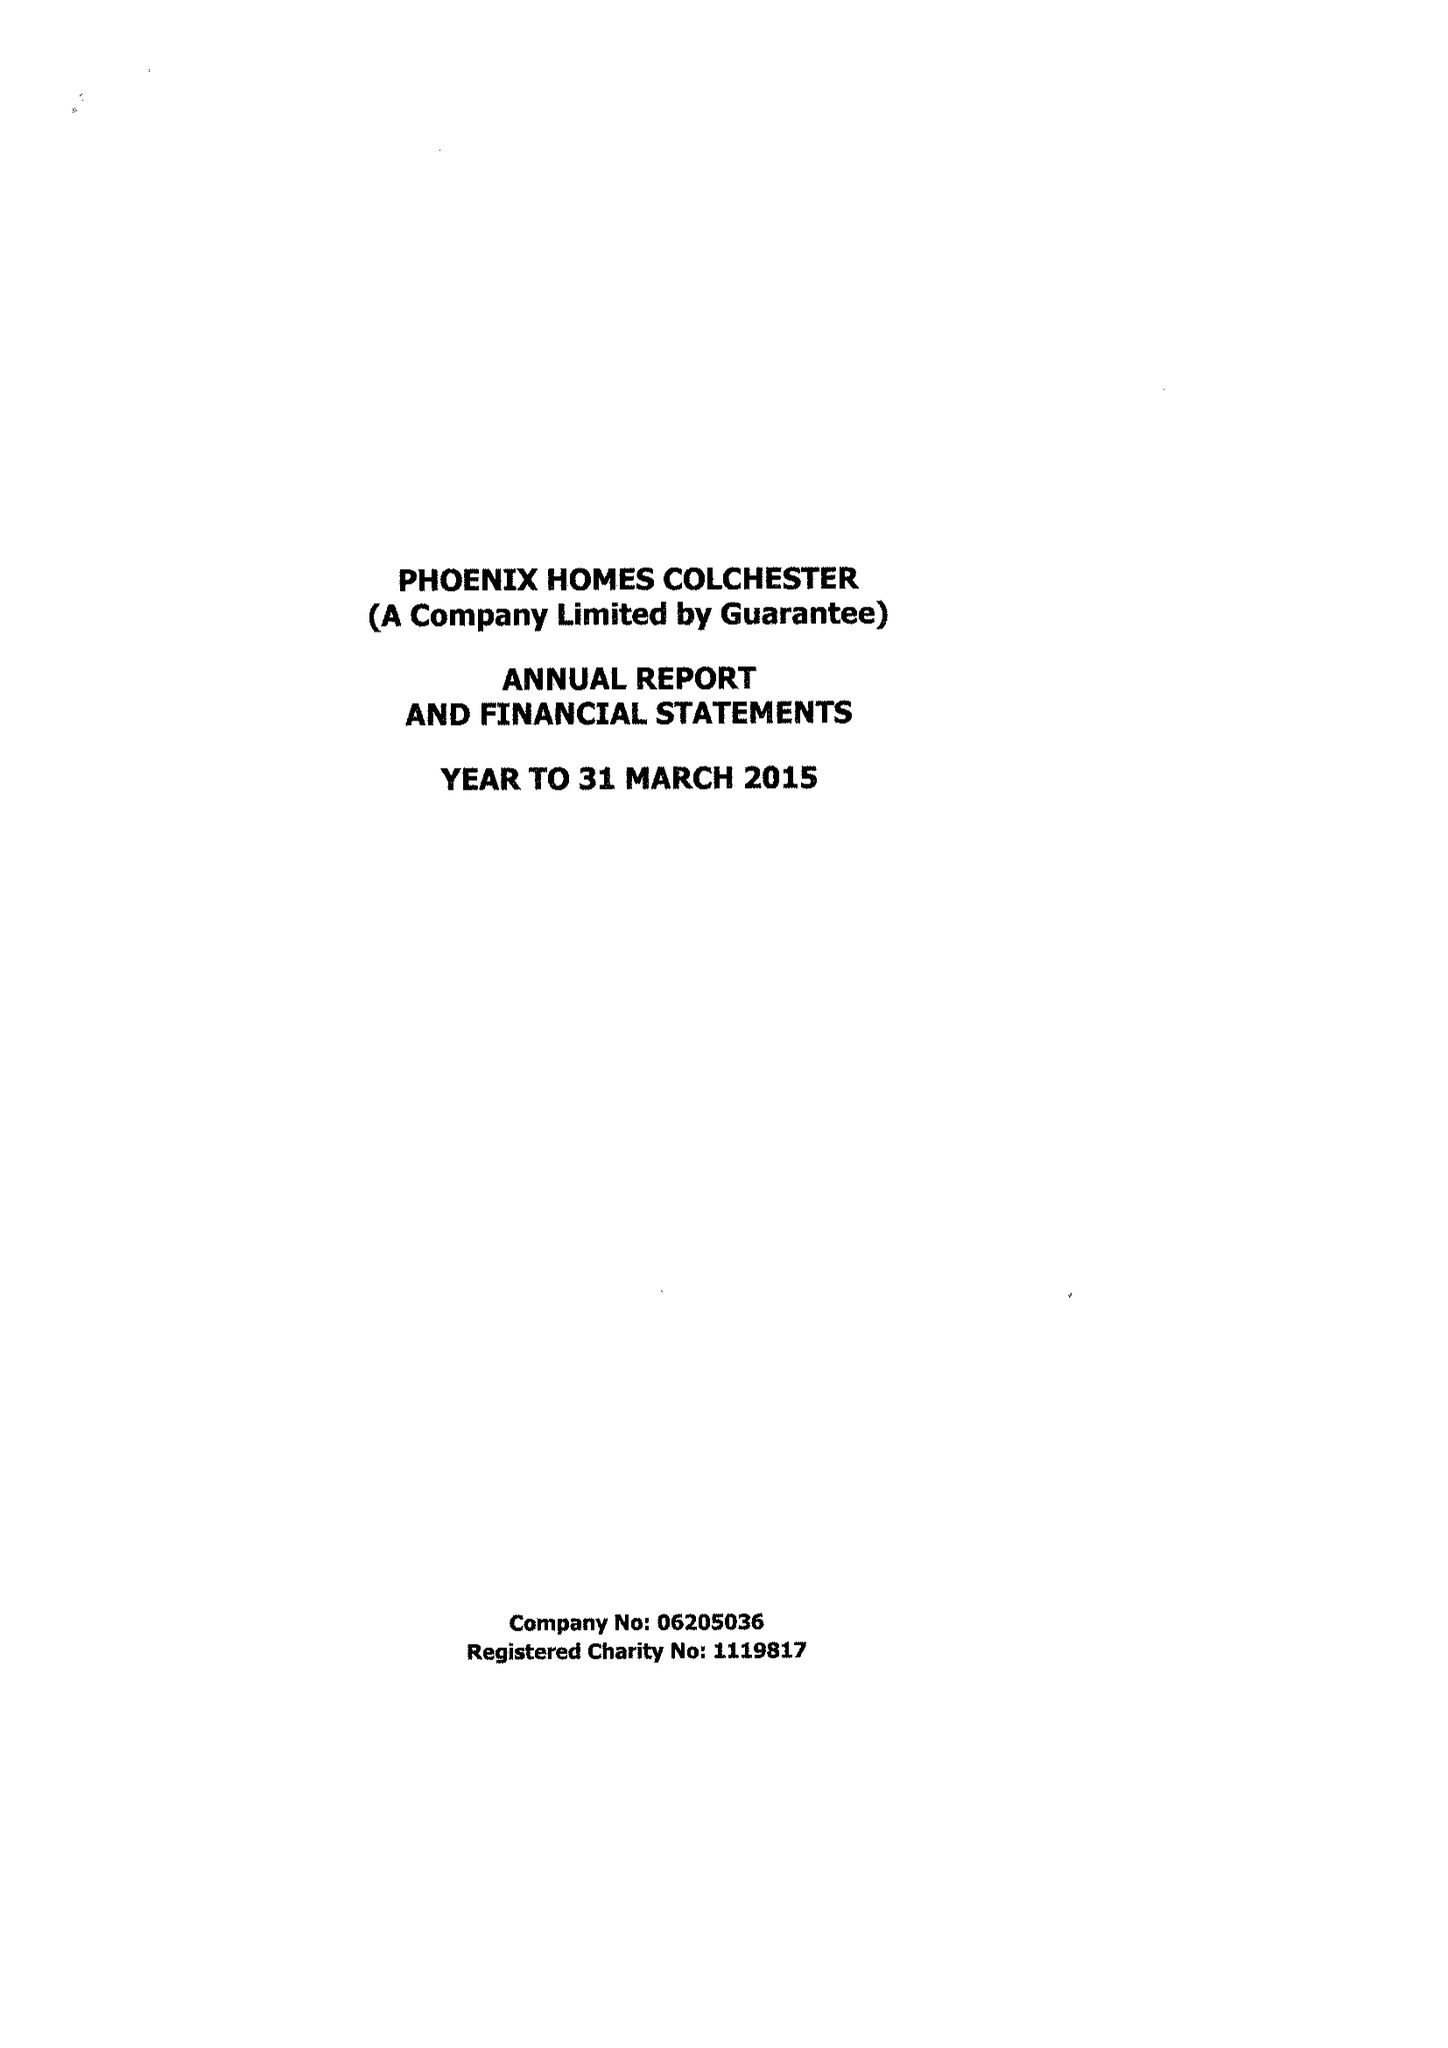What is the value for the address__post_town?
Answer the question using a single word or phrase. COLCHESTER 